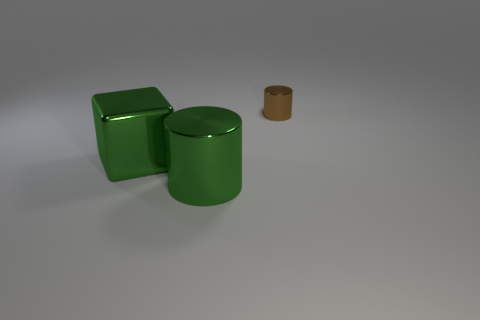Add 3 gray rubber cylinders. How many objects exist? 6 Subtract all green cylinders. How many cylinders are left? 1 Subtract all cylinders. How many objects are left? 1 Subtract all brown balls. How many brown cylinders are left? 1 Subtract all brown cylinders. Subtract all big blocks. How many objects are left? 1 Add 3 big green things. How many big green things are left? 5 Add 2 big things. How many big things exist? 4 Subtract 0 red blocks. How many objects are left? 3 Subtract all blue blocks. Subtract all brown spheres. How many blocks are left? 1 